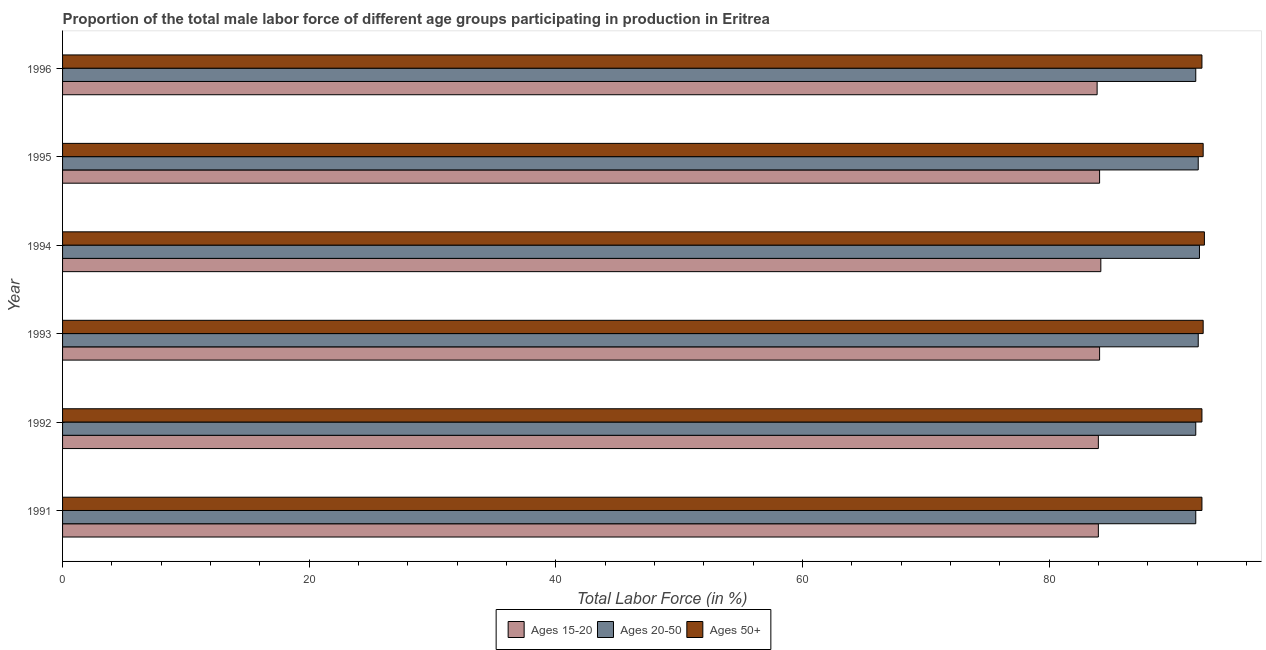Are the number of bars per tick equal to the number of legend labels?
Keep it short and to the point. Yes. How many bars are there on the 2nd tick from the top?
Keep it short and to the point. 3. In how many cases, is the number of bars for a given year not equal to the number of legend labels?
Your answer should be compact. 0. What is the percentage of male labor force within the age group 20-50 in 1995?
Your answer should be very brief. 92.1. Across all years, what is the maximum percentage of male labor force within the age group 15-20?
Provide a short and direct response. 84.2. Across all years, what is the minimum percentage of male labor force above age 50?
Your answer should be compact. 92.4. In which year was the percentage of male labor force within the age group 20-50 minimum?
Your answer should be very brief. 1991. What is the total percentage of male labor force above age 50 in the graph?
Offer a very short reply. 554.8. What is the difference between the percentage of male labor force above age 50 in 1992 and that in 1996?
Ensure brevity in your answer.  0. What is the difference between the percentage of male labor force within the age group 15-20 in 1994 and the percentage of male labor force above age 50 in 1995?
Your answer should be very brief. -8.3. What is the average percentage of male labor force above age 50 per year?
Your answer should be very brief. 92.47. In the year 1996, what is the difference between the percentage of male labor force within the age group 15-20 and percentage of male labor force above age 50?
Your answer should be compact. -8.5. In how many years, is the percentage of male labor force within the age group 20-50 greater than 52 %?
Keep it short and to the point. 6. What is the ratio of the percentage of male labor force within the age group 15-20 in 1993 to that in 1994?
Your answer should be compact. 1. Is the percentage of male labor force within the age group 15-20 in 1994 less than that in 1996?
Provide a succinct answer. No. Is the difference between the percentage of male labor force within the age group 20-50 in 1992 and 1994 greater than the difference between the percentage of male labor force above age 50 in 1992 and 1994?
Provide a succinct answer. No. What is the difference between the highest and the second highest percentage of male labor force above age 50?
Offer a terse response. 0.1. In how many years, is the percentage of male labor force within the age group 20-50 greater than the average percentage of male labor force within the age group 20-50 taken over all years?
Keep it short and to the point. 3. Is the sum of the percentage of male labor force within the age group 15-20 in 1993 and 1994 greater than the maximum percentage of male labor force above age 50 across all years?
Provide a short and direct response. Yes. What does the 3rd bar from the top in 1992 represents?
Your answer should be very brief. Ages 15-20. What does the 3rd bar from the bottom in 1994 represents?
Your response must be concise. Ages 50+. How many bars are there?
Provide a succinct answer. 18. Are all the bars in the graph horizontal?
Offer a very short reply. Yes. How many years are there in the graph?
Ensure brevity in your answer.  6. What is the difference between two consecutive major ticks on the X-axis?
Your response must be concise. 20. Are the values on the major ticks of X-axis written in scientific E-notation?
Ensure brevity in your answer.  No. Does the graph contain grids?
Your answer should be very brief. No. Where does the legend appear in the graph?
Give a very brief answer. Bottom center. How many legend labels are there?
Your answer should be compact. 3. What is the title of the graph?
Provide a succinct answer. Proportion of the total male labor force of different age groups participating in production in Eritrea. Does "Female employers" appear as one of the legend labels in the graph?
Ensure brevity in your answer.  No. What is the label or title of the X-axis?
Offer a very short reply. Total Labor Force (in %). What is the Total Labor Force (in %) in Ages 15-20 in 1991?
Ensure brevity in your answer.  84. What is the Total Labor Force (in %) of Ages 20-50 in 1991?
Keep it short and to the point. 91.9. What is the Total Labor Force (in %) in Ages 50+ in 1991?
Offer a terse response. 92.4. What is the Total Labor Force (in %) of Ages 15-20 in 1992?
Keep it short and to the point. 84. What is the Total Labor Force (in %) in Ages 20-50 in 1992?
Your answer should be very brief. 91.9. What is the Total Labor Force (in %) in Ages 50+ in 1992?
Offer a very short reply. 92.4. What is the Total Labor Force (in %) in Ages 15-20 in 1993?
Keep it short and to the point. 84.1. What is the Total Labor Force (in %) of Ages 20-50 in 1993?
Offer a very short reply. 92.1. What is the Total Labor Force (in %) in Ages 50+ in 1993?
Offer a very short reply. 92.5. What is the Total Labor Force (in %) in Ages 15-20 in 1994?
Make the answer very short. 84.2. What is the Total Labor Force (in %) of Ages 20-50 in 1994?
Give a very brief answer. 92.2. What is the Total Labor Force (in %) of Ages 50+ in 1994?
Provide a succinct answer. 92.6. What is the Total Labor Force (in %) of Ages 15-20 in 1995?
Provide a succinct answer. 84.1. What is the Total Labor Force (in %) of Ages 20-50 in 1995?
Keep it short and to the point. 92.1. What is the Total Labor Force (in %) of Ages 50+ in 1995?
Keep it short and to the point. 92.5. What is the Total Labor Force (in %) in Ages 15-20 in 1996?
Offer a very short reply. 83.9. What is the Total Labor Force (in %) of Ages 20-50 in 1996?
Make the answer very short. 91.9. What is the Total Labor Force (in %) in Ages 50+ in 1996?
Make the answer very short. 92.4. Across all years, what is the maximum Total Labor Force (in %) of Ages 15-20?
Provide a short and direct response. 84.2. Across all years, what is the maximum Total Labor Force (in %) of Ages 20-50?
Your response must be concise. 92.2. Across all years, what is the maximum Total Labor Force (in %) in Ages 50+?
Provide a short and direct response. 92.6. Across all years, what is the minimum Total Labor Force (in %) in Ages 15-20?
Provide a short and direct response. 83.9. Across all years, what is the minimum Total Labor Force (in %) in Ages 20-50?
Your answer should be very brief. 91.9. Across all years, what is the minimum Total Labor Force (in %) in Ages 50+?
Keep it short and to the point. 92.4. What is the total Total Labor Force (in %) in Ages 15-20 in the graph?
Your answer should be compact. 504.3. What is the total Total Labor Force (in %) of Ages 20-50 in the graph?
Your answer should be compact. 552.1. What is the total Total Labor Force (in %) in Ages 50+ in the graph?
Give a very brief answer. 554.8. What is the difference between the Total Labor Force (in %) of Ages 20-50 in 1991 and that in 1992?
Offer a terse response. 0. What is the difference between the Total Labor Force (in %) of Ages 15-20 in 1991 and that in 1993?
Provide a short and direct response. -0.1. What is the difference between the Total Labor Force (in %) in Ages 20-50 in 1991 and that in 1993?
Your answer should be very brief. -0.2. What is the difference between the Total Labor Force (in %) in Ages 15-20 in 1991 and that in 1994?
Keep it short and to the point. -0.2. What is the difference between the Total Labor Force (in %) of Ages 20-50 in 1991 and that in 1994?
Offer a very short reply. -0.3. What is the difference between the Total Labor Force (in %) in Ages 50+ in 1991 and that in 1994?
Your answer should be compact. -0.2. What is the difference between the Total Labor Force (in %) of Ages 15-20 in 1991 and that in 1995?
Your response must be concise. -0.1. What is the difference between the Total Labor Force (in %) in Ages 50+ in 1991 and that in 1995?
Your answer should be very brief. -0.1. What is the difference between the Total Labor Force (in %) of Ages 15-20 in 1991 and that in 1996?
Your answer should be very brief. 0.1. What is the difference between the Total Labor Force (in %) of Ages 50+ in 1991 and that in 1996?
Make the answer very short. 0. What is the difference between the Total Labor Force (in %) in Ages 20-50 in 1992 and that in 1993?
Provide a short and direct response. -0.2. What is the difference between the Total Labor Force (in %) in Ages 15-20 in 1992 and that in 1994?
Ensure brevity in your answer.  -0.2. What is the difference between the Total Labor Force (in %) of Ages 20-50 in 1992 and that in 1994?
Provide a short and direct response. -0.3. What is the difference between the Total Labor Force (in %) of Ages 15-20 in 1992 and that in 1995?
Make the answer very short. -0.1. What is the difference between the Total Labor Force (in %) in Ages 50+ in 1992 and that in 1995?
Your response must be concise. -0.1. What is the difference between the Total Labor Force (in %) in Ages 15-20 in 1993 and that in 1994?
Keep it short and to the point. -0.1. What is the difference between the Total Labor Force (in %) of Ages 15-20 in 1993 and that in 1995?
Keep it short and to the point. 0. What is the difference between the Total Labor Force (in %) in Ages 20-50 in 1993 and that in 1995?
Provide a succinct answer. 0. What is the difference between the Total Labor Force (in %) in Ages 50+ in 1993 and that in 1996?
Provide a short and direct response. 0.1. What is the difference between the Total Labor Force (in %) in Ages 20-50 in 1994 and that in 1996?
Offer a very short reply. 0.3. What is the difference between the Total Labor Force (in %) of Ages 15-20 in 1995 and that in 1996?
Your answer should be compact. 0.2. What is the difference between the Total Labor Force (in %) in Ages 20-50 in 1995 and that in 1996?
Give a very brief answer. 0.2. What is the difference between the Total Labor Force (in %) in Ages 50+ in 1995 and that in 1996?
Offer a terse response. 0.1. What is the difference between the Total Labor Force (in %) in Ages 15-20 in 1991 and the Total Labor Force (in %) in Ages 50+ in 1992?
Offer a very short reply. -8.4. What is the difference between the Total Labor Force (in %) in Ages 15-20 in 1991 and the Total Labor Force (in %) in Ages 20-50 in 1993?
Offer a terse response. -8.1. What is the difference between the Total Labor Force (in %) of Ages 15-20 in 1991 and the Total Labor Force (in %) of Ages 20-50 in 1994?
Offer a very short reply. -8.2. What is the difference between the Total Labor Force (in %) in Ages 15-20 in 1991 and the Total Labor Force (in %) in Ages 20-50 in 1995?
Give a very brief answer. -8.1. What is the difference between the Total Labor Force (in %) of Ages 15-20 in 1991 and the Total Labor Force (in %) of Ages 50+ in 1995?
Offer a terse response. -8.5. What is the difference between the Total Labor Force (in %) of Ages 20-50 in 1991 and the Total Labor Force (in %) of Ages 50+ in 1995?
Offer a terse response. -0.6. What is the difference between the Total Labor Force (in %) of Ages 15-20 in 1991 and the Total Labor Force (in %) of Ages 20-50 in 1996?
Your answer should be very brief. -7.9. What is the difference between the Total Labor Force (in %) of Ages 20-50 in 1991 and the Total Labor Force (in %) of Ages 50+ in 1996?
Keep it short and to the point. -0.5. What is the difference between the Total Labor Force (in %) of Ages 20-50 in 1992 and the Total Labor Force (in %) of Ages 50+ in 1993?
Provide a short and direct response. -0.6. What is the difference between the Total Labor Force (in %) of Ages 20-50 in 1992 and the Total Labor Force (in %) of Ages 50+ in 1994?
Make the answer very short. -0.7. What is the difference between the Total Labor Force (in %) of Ages 15-20 in 1992 and the Total Labor Force (in %) of Ages 20-50 in 1995?
Keep it short and to the point. -8.1. What is the difference between the Total Labor Force (in %) of Ages 15-20 in 1992 and the Total Labor Force (in %) of Ages 50+ in 1995?
Keep it short and to the point. -8.5. What is the difference between the Total Labor Force (in %) of Ages 20-50 in 1992 and the Total Labor Force (in %) of Ages 50+ in 1995?
Your response must be concise. -0.6. What is the difference between the Total Labor Force (in %) in Ages 15-20 in 1992 and the Total Labor Force (in %) in Ages 20-50 in 1996?
Ensure brevity in your answer.  -7.9. What is the difference between the Total Labor Force (in %) of Ages 15-20 in 1992 and the Total Labor Force (in %) of Ages 50+ in 1996?
Give a very brief answer. -8.4. What is the difference between the Total Labor Force (in %) in Ages 20-50 in 1992 and the Total Labor Force (in %) in Ages 50+ in 1996?
Keep it short and to the point. -0.5. What is the difference between the Total Labor Force (in %) of Ages 20-50 in 1993 and the Total Labor Force (in %) of Ages 50+ in 1994?
Give a very brief answer. -0.5. What is the difference between the Total Labor Force (in %) of Ages 20-50 in 1993 and the Total Labor Force (in %) of Ages 50+ in 1996?
Keep it short and to the point. -0.3. What is the difference between the Total Labor Force (in %) in Ages 15-20 in 1994 and the Total Labor Force (in %) in Ages 20-50 in 1995?
Provide a short and direct response. -7.9. What is the difference between the Total Labor Force (in %) of Ages 20-50 in 1994 and the Total Labor Force (in %) of Ages 50+ in 1995?
Offer a terse response. -0.3. What is the difference between the Total Labor Force (in %) of Ages 15-20 in 1994 and the Total Labor Force (in %) of Ages 20-50 in 1996?
Your answer should be compact. -7.7. What is the difference between the Total Labor Force (in %) in Ages 15-20 in 1995 and the Total Labor Force (in %) in Ages 50+ in 1996?
Your answer should be very brief. -8.3. What is the difference between the Total Labor Force (in %) in Ages 20-50 in 1995 and the Total Labor Force (in %) in Ages 50+ in 1996?
Offer a terse response. -0.3. What is the average Total Labor Force (in %) of Ages 15-20 per year?
Provide a succinct answer. 84.05. What is the average Total Labor Force (in %) of Ages 20-50 per year?
Make the answer very short. 92.02. What is the average Total Labor Force (in %) of Ages 50+ per year?
Your answer should be very brief. 92.47. In the year 1991, what is the difference between the Total Labor Force (in %) in Ages 15-20 and Total Labor Force (in %) in Ages 50+?
Your answer should be very brief. -8.4. In the year 1993, what is the difference between the Total Labor Force (in %) in Ages 15-20 and Total Labor Force (in %) in Ages 20-50?
Your response must be concise. -8. In the year 1994, what is the difference between the Total Labor Force (in %) of Ages 15-20 and Total Labor Force (in %) of Ages 50+?
Your response must be concise. -8.4. In the year 1994, what is the difference between the Total Labor Force (in %) in Ages 20-50 and Total Labor Force (in %) in Ages 50+?
Offer a very short reply. -0.4. In the year 1995, what is the difference between the Total Labor Force (in %) of Ages 15-20 and Total Labor Force (in %) of Ages 20-50?
Ensure brevity in your answer.  -8. In the year 1995, what is the difference between the Total Labor Force (in %) in Ages 20-50 and Total Labor Force (in %) in Ages 50+?
Make the answer very short. -0.4. In the year 1996, what is the difference between the Total Labor Force (in %) in Ages 15-20 and Total Labor Force (in %) in Ages 20-50?
Your answer should be compact. -8. What is the ratio of the Total Labor Force (in %) in Ages 15-20 in 1991 to that in 1992?
Offer a very short reply. 1. What is the ratio of the Total Labor Force (in %) in Ages 50+ in 1991 to that in 1992?
Offer a very short reply. 1. What is the ratio of the Total Labor Force (in %) in Ages 15-20 in 1991 to that in 1993?
Give a very brief answer. 1. What is the ratio of the Total Labor Force (in %) in Ages 15-20 in 1991 to that in 1994?
Provide a succinct answer. 1. What is the ratio of the Total Labor Force (in %) in Ages 20-50 in 1991 to that in 1994?
Make the answer very short. 1. What is the ratio of the Total Labor Force (in %) of Ages 50+ in 1991 to that in 1994?
Ensure brevity in your answer.  1. What is the ratio of the Total Labor Force (in %) in Ages 15-20 in 1991 to that in 1995?
Keep it short and to the point. 1. What is the ratio of the Total Labor Force (in %) in Ages 15-20 in 1991 to that in 1996?
Offer a terse response. 1. What is the ratio of the Total Labor Force (in %) of Ages 15-20 in 1992 to that in 1993?
Make the answer very short. 1. What is the ratio of the Total Labor Force (in %) of Ages 50+ in 1992 to that in 1993?
Your answer should be very brief. 1. What is the ratio of the Total Labor Force (in %) in Ages 20-50 in 1992 to that in 1995?
Provide a short and direct response. 1. What is the ratio of the Total Labor Force (in %) in Ages 20-50 in 1992 to that in 1996?
Provide a succinct answer. 1. What is the ratio of the Total Labor Force (in %) in Ages 50+ in 1992 to that in 1996?
Give a very brief answer. 1. What is the ratio of the Total Labor Force (in %) in Ages 15-20 in 1993 to that in 1994?
Make the answer very short. 1. What is the ratio of the Total Labor Force (in %) in Ages 15-20 in 1993 to that in 1995?
Your answer should be very brief. 1. What is the ratio of the Total Labor Force (in %) of Ages 50+ in 1993 to that in 1995?
Give a very brief answer. 1. What is the ratio of the Total Labor Force (in %) of Ages 50+ in 1993 to that in 1996?
Offer a very short reply. 1. What is the ratio of the Total Labor Force (in %) in Ages 50+ in 1994 to that in 1995?
Ensure brevity in your answer.  1. What is the ratio of the Total Labor Force (in %) of Ages 15-20 in 1995 to that in 1996?
Ensure brevity in your answer.  1. What is the ratio of the Total Labor Force (in %) in Ages 50+ in 1995 to that in 1996?
Offer a terse response. 1. What is the difference between the highest and the second highest Total Labor Force (in %) of Ages 20-50?
Offer a terse response. 0.1. What is the difference between the highest and the second highest Total Labor Force (in %) in Ages 50+?
Your response must be concise. 0.1. What is the difference between the highest and the lowest Total Labor Force (in %) of Ages 15-20?
Offer a very short reply. 0.3. 